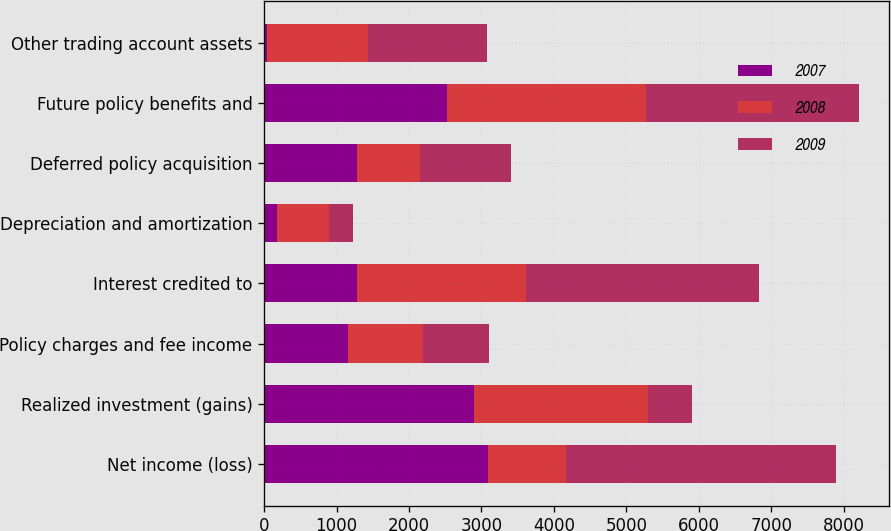Convert chart. <chart><loc_0><loc_0><loc_500><loc_500><stacked_bar_chart><ecel><fcel>Net income (loss)<fcel>Realized investment (gains)<fcel>Policy charges and fee income<fcel>Interest credited to<fcel>Depreciation and amortization<fcel>Deferred policy acquisition<fcel>Future policy benefits and<fcel>Other trading account assets<nl><fcel>2007<fcel>3090<fcel>2896<fcel>1152<fcel>1277<fcel>175<fcel>1277<fcel>2524<fcel>45<nl><fcel>2008<fcel>1081<fcel>2399<fcel>1043<fcel>2335<fcel>717<fcel>879<fcel>2749<fcel>1388<nl><fcel>2009<fcel>3729<fcel>613<fcel>915<fcel>3222<fcel>339<fcel>1253<fcel>2941<fcel>1649<nl></chart> 